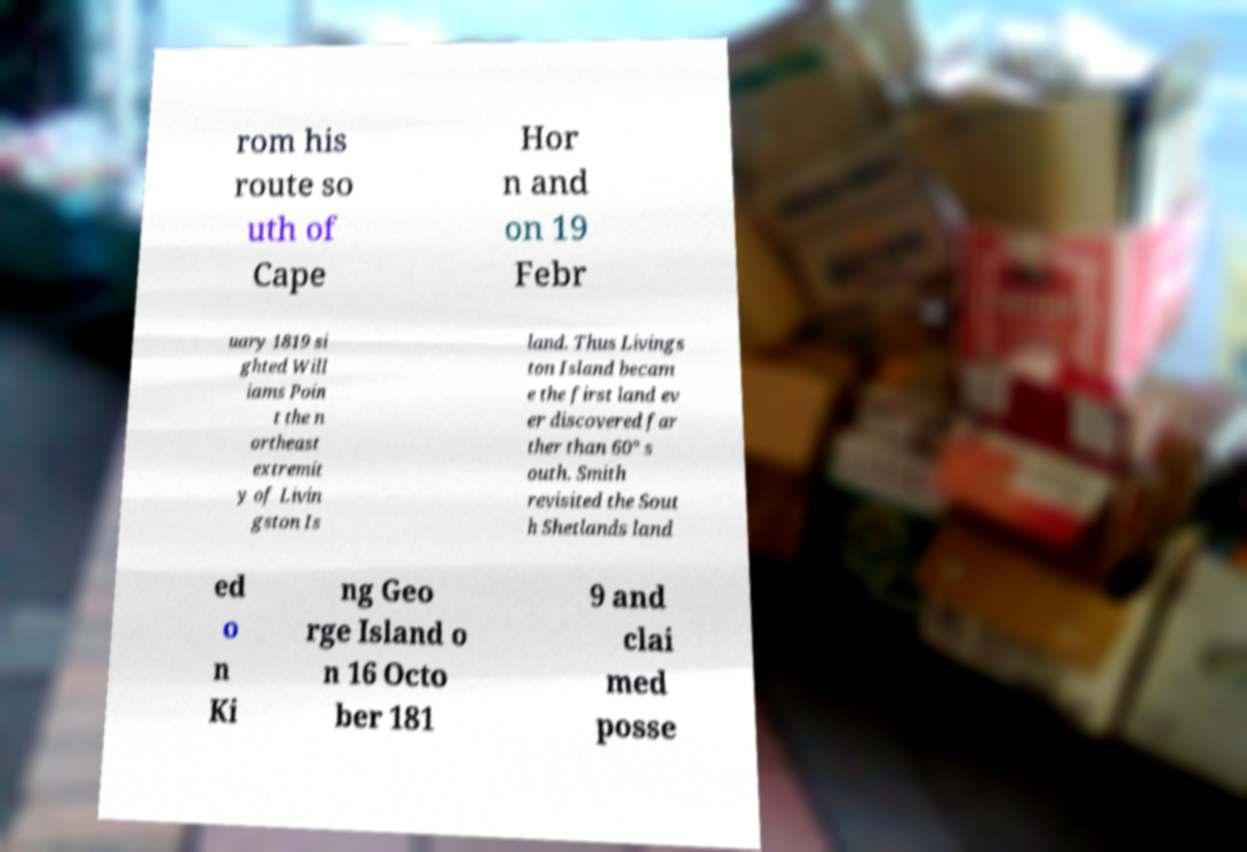Please identify and transcribe the text found in this image. rom his route so uth of Cape Hor n and on 19 Febr uary 1819 si ghted Will iams Poin t the n ortheast extremit y of Livin gston Is land. Thus Livings ton Island becam e the first land ev er discovered far ther than 60° s outh. Smith revisited the Sout h Shetlands land ed o n Ki ng Geo rge Island o n 16 Octo ber 181 9 and clai med posse 